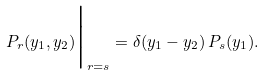Convert formula to latex. <formula><loc_0><loc_0><loc_500><loc_500>P _ { r } ( y _ { 1 } , y _ { 2 } ) \Big | _ { r = s } = \delta ( y _ { 1 } - y _ { 2 } ) \, P _ { s } ( y _ { 1 } ) .</formula> 